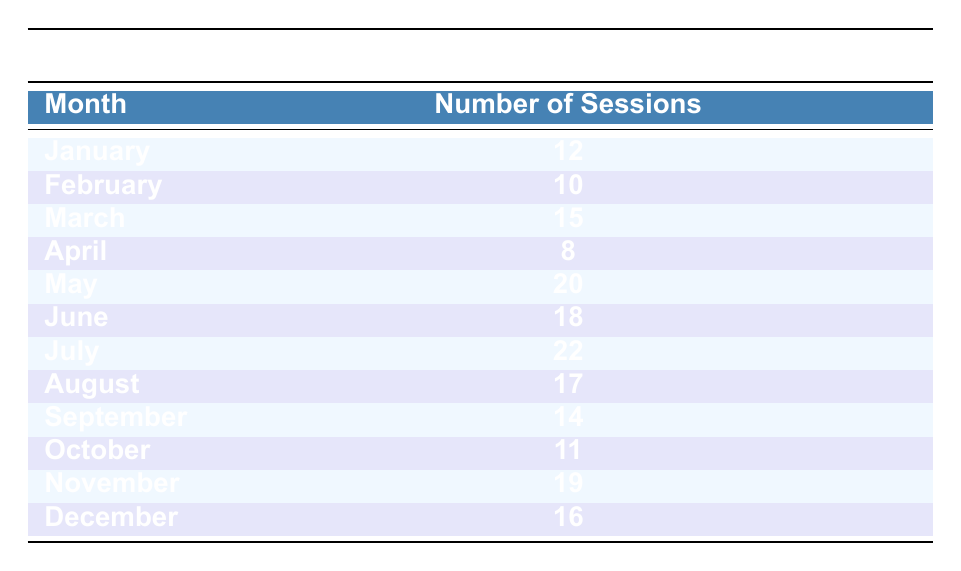What was the month with the highest number of voice acting sessions completed? Referring to the table, July has the highest number of sessions, which is 22.
Answer: July How many voice acting sessions were completed in November? The table shows that in November, 19 sessions were completed.
Answer: 19 What is the total number of sessions completed from January to March? To find the total, sum the sessions: 12 (January) + 10 (February) + 15 (March) = 37.
Answer: 37 Which month had fewer sessions completed: April or October? April had 8 sessions and October had 11 sessions. Since 8 is less than 11, April had fewer sessions.
Answer: April What is the average number of voice acting sessions completed per month? First, sum all sessions: 12 + 10 + 15 + 8 + 20 + 18 + 22 + 17 + 14 + 11 + 19 + 16 =  192. Then divide by the number of months (12): 192/12 = 16.
Answer: 16 Did more sessions get completed in June than in March? June had 18 sessions and March had 15 sessions. Since 18 is greater than 15, more sessions were completed in June.
Answer: Yes Which month saw a decrease in sessions compared to the previous month? Compare each month to its previous month: April (8) has fewer than March (15), and October (11) has fewer than November (19). Thus, both April and October saw decreases.
Answer: April and October What is the difference in sessions completed between the months of July and May? July had 22 sessions and May had 20 sessions. The difference is 22 - 20 = 2.
Answer: 2 Is the number of sessions completed in August greater than or equal to the number completed in September? August had 17 sessions, while September had 14 sessions. Since 17 is greater than 14, August had more sessions.
Answer: Yes 